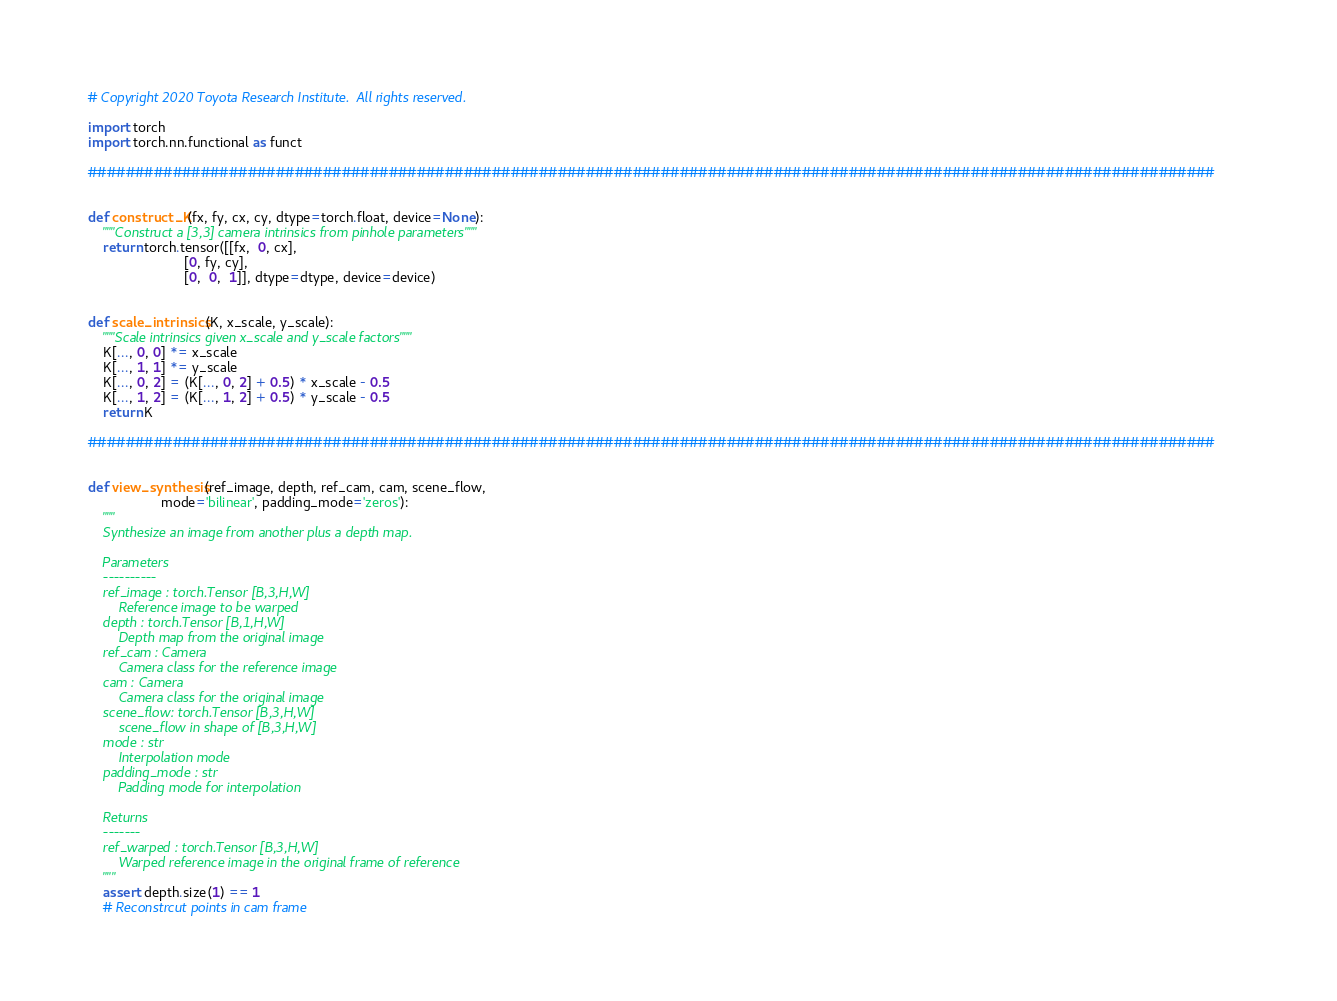<code> <loc_0><loc_0><loc_500><loc_500><_Python_># Copyright 2020 Toyota Research Institute.  All rights reserved.

import torch
import torch.nn.functional as funct

########################################################################################################################


def construct_K(fx, fy, cx, cy, dtype=torch.float, device=None):
    """Construct a [3,3] camera intrinsics from pinhole parameters"""
    return torch.tensor([[fx,  0, cx],
                         [0, fy, cy],
                         [0,  0,  1]], dtype=dtype, device=device)


def scale_intrinsics(K, x_scale, y_scale):
    """Scale intrinsics given x_scale and y_scale factors"""
    K[..., 0, 0] *= x_scale
    K[..., 1, 1] *= y_scale
    K[..., 0, 2] = (K[..., 0, 2] + 0.5) * x_scale - 0.5
    K[..., 1, 2] = (K[..., 1, 2] + 0.5) * y_scale - 0.5
    return K

########################################################################################################################


def view_synthesis(ref_image, depth, ref_cam, cam, scene_flow,
                   mode='bilinear', padding_mode='zeros'):
    """
    Synthesize an image from another plus a depth map.

    Parameters
    ----------
    ref_image : torch.Tensor [B,3,H,W]
        Reference image to be warped
    depth : torch.Tensor [B,1,H,W]
        Depth map from the original image
    ref_cam : Camera
        Camera class for the reference image
    cam : Camera
        Camera class for the original image
    scene_flow: torch.Tensor [B,3,H,W]
        scene_flow in shape of [B,3,H,W]
    mode : str
        Interpolation mode
    padding_mode : str
        Padding mode for interpolation

    Returns
    -------
    ref_warped : torch.Tensor [B,3,H,W]
        Warped reference image in the original frame of reference
    """
    assert depth.size(1) == 1
    # Reconstrcut points in cam frame</code> 